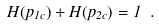<formula> <loc_0><loc_0><loc_500><loc_500>H ( p _ { 1 c } ) + H ( p _ { 2 c } ) = 1 \ .</formula> 